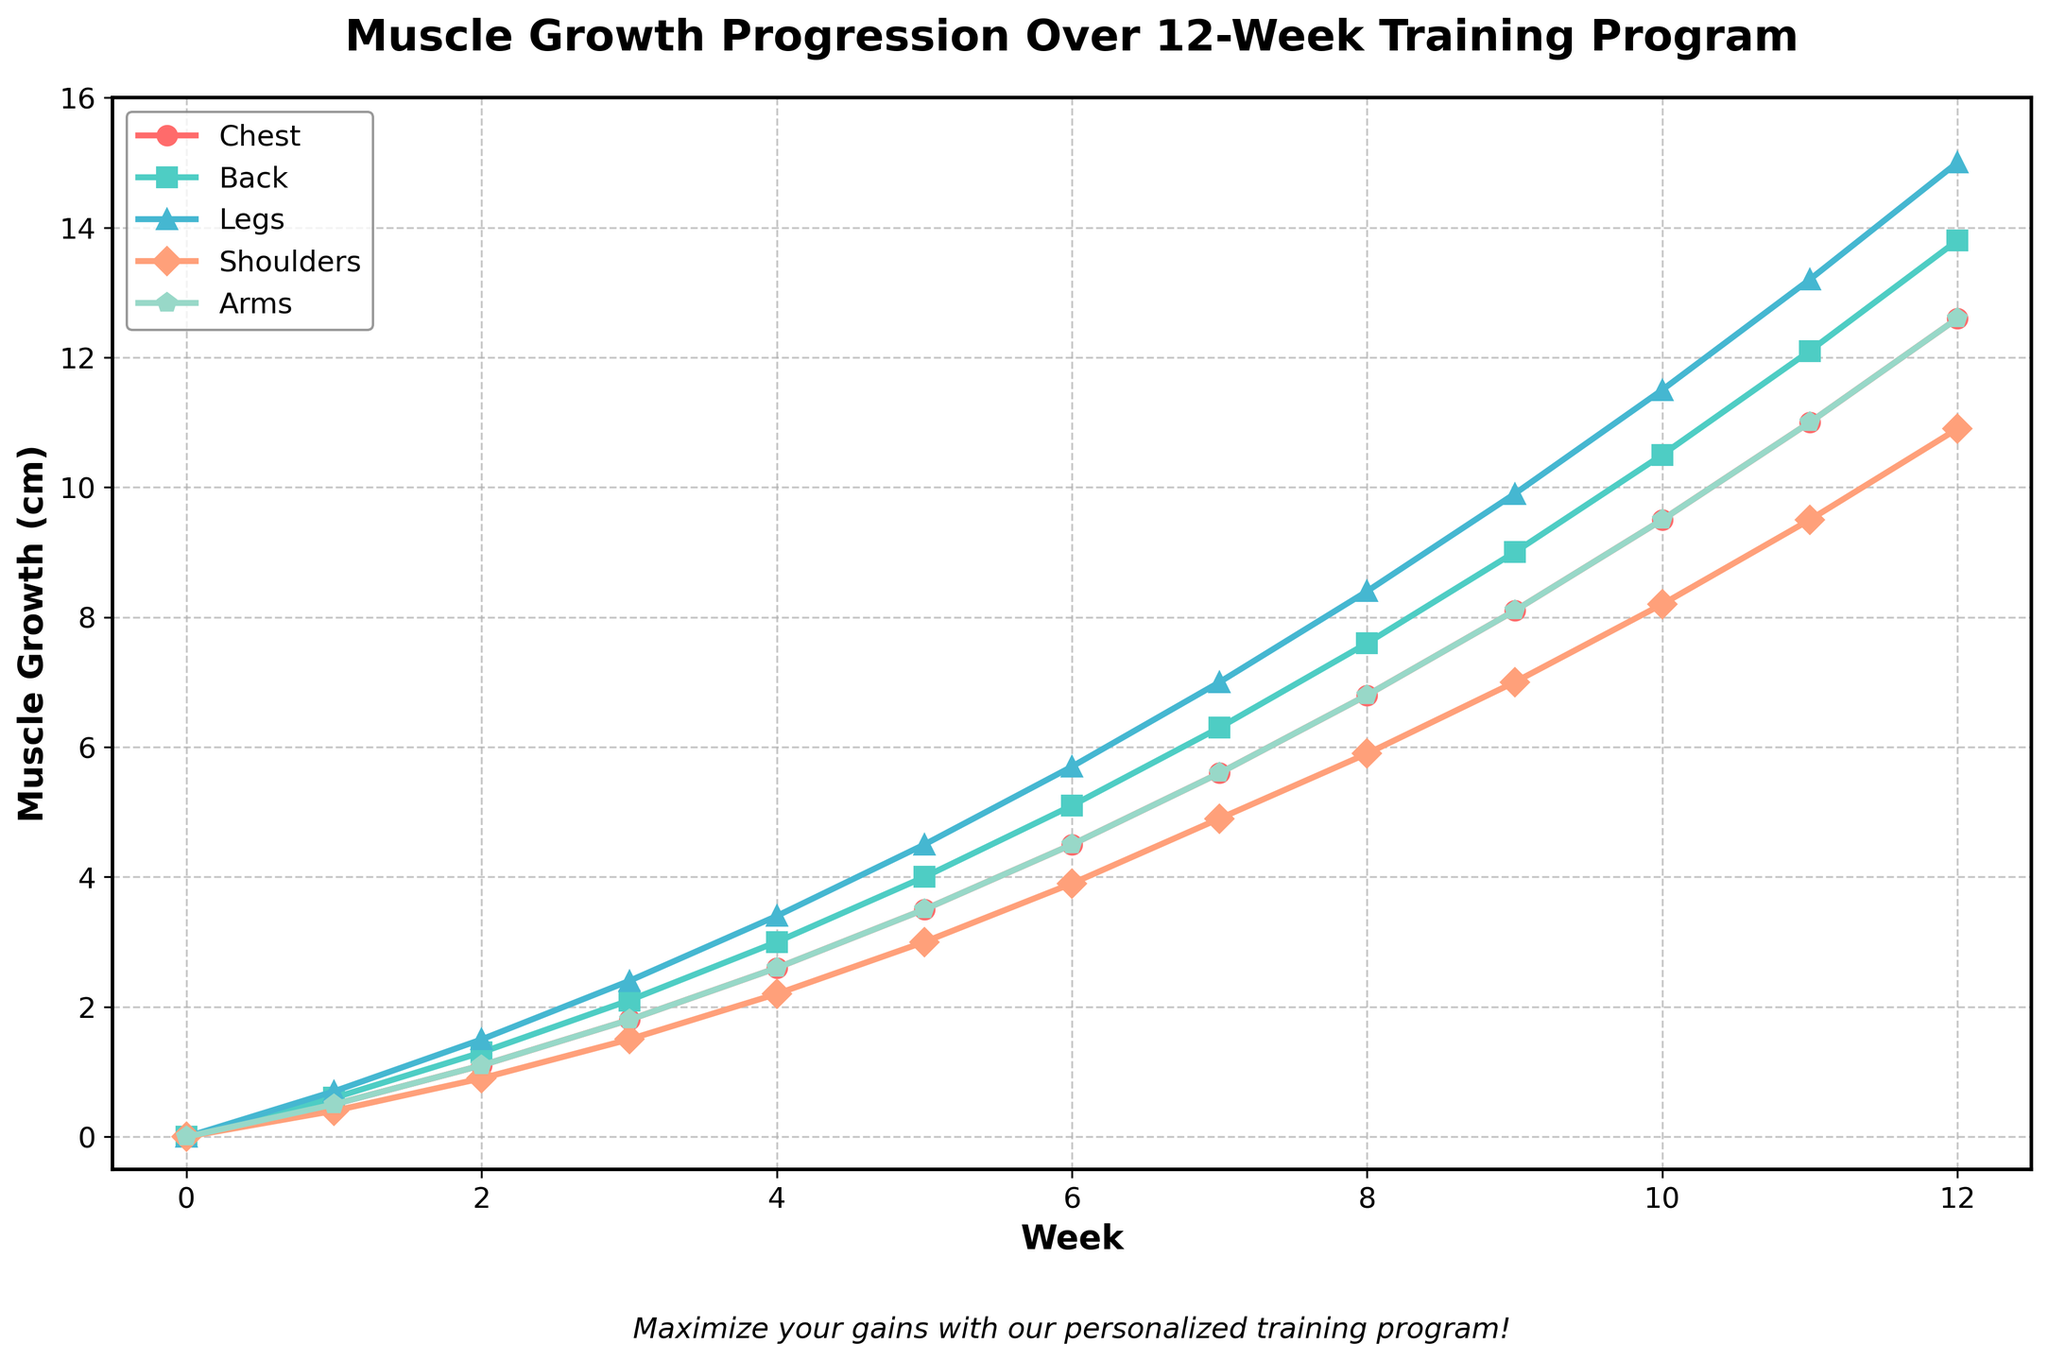Which muscle group shows the most growth by week 6? By looking at the figure, we can see the values of each muscle group at week 6. The muscle group with the highest value at week 6 is Legs at 5.7 cm.
Answer: Legs What is the difference in muscle growth between the Arms and Shoulders at week 8? For week 8, locate the values for Arms and Shoulders on the chart. The Arms are at 6.8 cm and the Shoulders are at 5.9 cm. The difference is 6.8 - 5.9 = 0.9 cm.
Answer: 0.9 cm How do the growth rates of the Chest and Back compare from week 0 to week 12? Check the growth of the Chest and Back at week 0 and week 12. The growth for Chest is 12.6 cm (12.6 - 0) and for Back is 13.8 cm (13.8 - 0). The Back has a slightly higher growth rate compared to Chest.
Answer: Back has a higher growth rate Which muscle group has the least growth in the first four weeks? Examine the chart for muscle growth values at week 4. The values are: Chest = 2.6 cm, Back = 3.0 cm, Legs = 3.4 cm, Shoulders = 2.2 cm, Arms = 2.6 cm. Shoulders have the least growth at 2.2 cm.
Answer: Shoulders What is the average muscle growth across all muscle groups at week 10? For week 10, find the muscle growth values: Chest = 9.5 cm, Back = 10.5 cm, Legs = 11.5 cm, Shoulders = 8.2 cm, Arms = 9.5 cm. Sum them up to get 9.5 + 10.5 + 11.5 + 8.2 + 9.5 = 49.2 cm. The average is 49.2 / 5 = 9.84 cm.
Answer: 9.84 cm Between which two consecutive weeks does the Legs muscle group show the greatest increase? Inspect the Legs muscle group growth values across each week. Identify the week-to-week increase: Weeks 6 to 7 shows the largest increase from 5.7 cm to 7.0 cm, which is a 1.3 cm increase.
Answer: Weeks 6 to 7 Is the growth of Back always greater than the growth of Arms throughout the 12-week program? Compare the growth values of Back and Arms at each week. For every week, the Back values are higher than the Arms values (e.g., week 1: 0.6 vs 0.5, week 12: 13.8 vs 12.6).
Answer: Yes What is the median muscle growth for Shoulders at week 7? Median for one value is the value itself. At week 7, the growth for Shoulders is 4.9 cm. Hence, the median is 4.9 cm.
Answer: 4.9 cm How much more does the Back muscle grow compared to the Chest muscle by the end of week 12? At week 12, the growth for Back is 13.8 cm, and for Chest, it is 12.6 cm. The difference is 13.8 - 12.6 = 1.2 cm.
Answer: 1.2 cm 